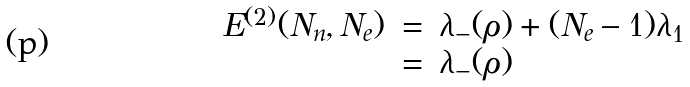<formula> <loc_0><loc_0><loc_500><loc_500>\begin{array} { l l l } E ^ { ( 2 ) } ( N _ { n } , N _ { e } ) & = & \lambda _ { - } ( \rho ) + ( N _ { e } - 1 ) \lambda _ { 1 } \\ & = & \lambda _ { - } ( \rho ) \end{array}</formula> 